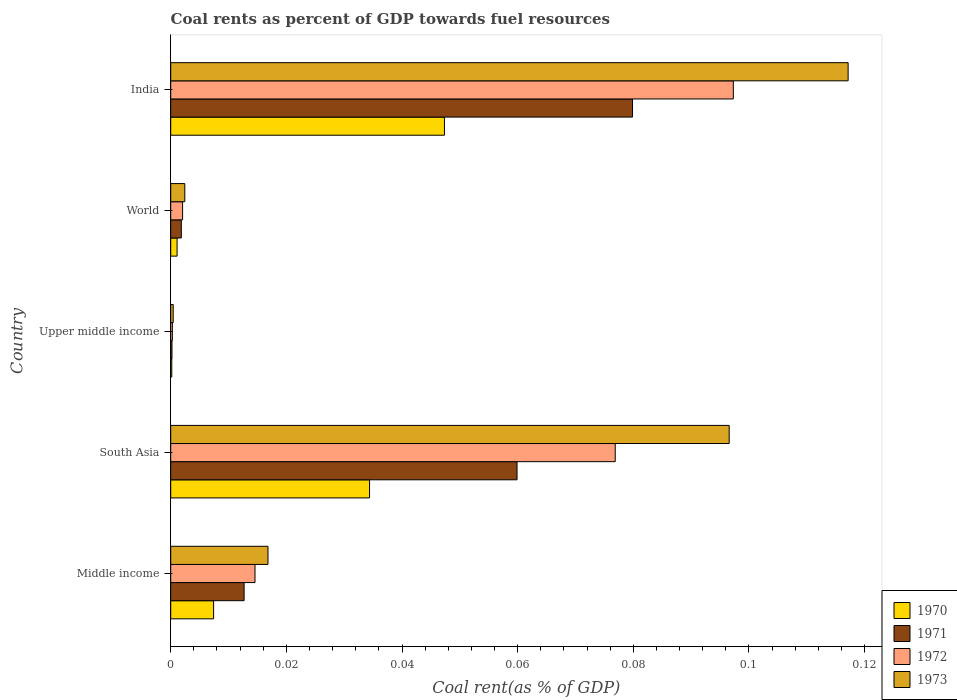How many different coloured bars are there?
Your answer should be very brief. 4. Are the number of bars per tick equal to the number of legend labels?
Give a very brief answer. Yes. How many bars are there on the 5th tick from the top?
Your answer should be very brief. 4. How many bars are there on the 2nd tick from the bottom?
Your answer should be compact. 4. What is the label of the 5th group of bars from the top?
Your answer should be compact. Middle income. In how many cases, is the number of bars for a given country not equal to the number of legend labels?
Your answer should be very brief. 0. What is the coal rent in 1972 in India?
Provide a short and direct response. 0.1. Across all countries, what is the maximum coal rent in 1971?
Provide a short and direct response. 0.08. Across all countries, what is the minimum coal rent in 1972?
Give a very brief answer. 0. In which country was the coal rent in 1973 minimum?
Offer a terse response. Upper middle income. What is the total coal rent in 1970 in the graph?
Make the answer very short. 0.09. What is the difference between the coal rent in 1973 in India and that in Upper middle income?
Your answer should be compact. 0.12. What is the difference between the coal rent in 1971 in World and the coal rent in 1972 in Upper middle income?
Offer a very short reply. 0. What is the average coal rent in 1970 per country?
Your response must be concise. 0.02. What is the difference between the coal rent in 1972 and coal rent in 1973 in South Asia?
Keep it short and to the point. -0.02. What is the ratio of the coal rent in 1973 in South Asia to that in World?
Your response must be concise. 39.65. Is the coal rent in 1972 in Upper middle income less than that in World?
Offer a terse response. Yes. What is the difference between the highest and the second highest coal rent in 1972?
Make the answer very short. 0.02. What is the difference between the highest and the lowest coal rent in 1971?
Offer a very short reply. 0.08. Is the sum of the coal rent in 1973 in India and South Asia greater than the maximum coal rent in 1972 across all countries?
Provide a short and direct response. Yes. What does the 4th bar from the bottom in Upper middle income represents?
Ensure brevity in your answer.  1973. Are all the bars in the graph horizontal?
Make the answer very short. Yes. Are the values on the major ticks of X-axis written in scientific E-notation?
Offer a very short reply. No. Does the graph contain grids?
Provide a succinct answer. No. How many legend labels are there?
Give a very brief answer. 4. How are the legend labels stacked?
Offer a terse response. Vertical. What is the title of the graph?
Offer a terse response. Coal rents as percent of GDP towards fuel resources. Does "1973" appear as one of the legend labels in the graph?
Offer a very short reply. Yes. What is the label or title of the X-axis?
Make the answer very short. Coal rent(as % of GDP). What is the label or title of the Y-axis?
Give a very brief answer. Country. What is the Coal rent(as % of GDP) of 1970 in Middle income?
Offer a terse response. 0.01. What is the Coal rent(as % of GDP) in 1971 in Middle income?
Make the answer very short. 0.01. What is the Coal rent(as % of GDP) of 1972 in Middle income?
Your answer should be very brief. 0.01. What is the Coal rent(as % of GDP) of 1973 in Middle income?
Ensure brevity in your answer.  0.02. What is the Coal rent(as % of GDP) of 1970 in South Asia?
Make the answer very short. 0.03. What is the Coal rent(as % of GDP) of 1971 in South Asia?
Keep it short and to the point. 0.06. What is the Coal rent(as % of GDP) in 1972 in South Asia?
Offer a very short reply. 0.08. What is the Coal rent(as % of GDP) in 1973 in South Asia?
Offer a very short reply. 0.1. What is the Coal rent(as % of GDP) in 1970 in Upper middle income?
Ensure brevity in your answer.  0. What is the Coal rent(as % of GDP) of 1971 in Upper middle income?
Provide a succinct answer. 0. What is the Coal rent(as % of GDP) of 1972 in Upper middle income?
Give a very brief answer. 0. What is the Coal rent(as % of GDP) in 1973 in Upper middle income?
Ensure brevity in your answer.  0. What is the Coal rent(as % of GDP) of 1970 in World?
Keep it short and to the point. 0. What is the Coal rent(as % of GDP) of 1971 in World?
Offer a terse response. 0. What is the Coal rent(as % of GDP) of 1972 in World?
Make the answer very short. 0. What is the Coal rent(as % of GDP) of 1973 in World?
Offer a terse response. 0. What is the Coal rent(as % of GDP) of 1970 in India?
Offer a terse response. 0.05. What is the Coal rent(as % of GDP) in 1971 in India?
Provide a short and direct response. 0.08. What is the Coal rent(as % of GDP) of 1972 in India?
Give a very brief answer. 0.1. What is the Coal rent(as % of GDP) in 1973 in India?
Keep it short and to the point. 0.12. Across all countries, what is the maximum Coal rent(as % of GDP) in 1970?
Your answer should be compact. 0.05. Across all countries, what is the maximum Coal rent(as % of GDP) of 1971?
Your answer should be very brief. 0.08. Across all countries, what is the maximum Coal rent(as % of GDP) in 1972?
Your answer should be very brief. 0.1. Across all countries, what is the maximum Coal rent(as % of GDP) of 1973?
Provide a succinct answer. 0.12. Across all countries, what is the minimum Coal rent(as % of GDP) in 1970?
Offer a terse response. 0. Across all countries, what is the minimum Coal rent(as % of GDP) of 1971?
Provide a short and direct response. 0. Across all countries, what is the minimum Coal rent(as % of GDP) in 1972?
Your response must be concise. 0. Across all countries, what is the minimum Coal rent(as % of GDP) in 1973?
Offer a terse response. 0. What is the total Coal rent(as % of GDP) in 1970 in the graph?
Your answer should be compact. 0.09. What is the total Coal rent(as % of GDP) of 1971 in the graph?
Your answer should be very brief. 0.15. What is the total Coal rent(as % of GDP) in 1972 in the graph?
Keep it short and to the point. 0.19. What is the total Coal rent(as % of GDP) of 1973 in the graph?
Give a very brief answer. 0.23. What is the difference between the Coal rent(as % of GDP) in 1970 in Middle income and that in South Asia?
Give a very brief answer. -0.03. What is the difference between the Coal rent(as % of GDP) in 1971 in Middle income and that in South Asia?
Your answer should be very brief. -0.05. What is the difference between the Coal rent(as % of GDP) in 1972 in Middle income and that in South Asia?
Provide a succinct answer. -0.06. What is the difference between the Coal rent(as % of GDP) in 1973 in Middle income and that in South Asia?
Ensure brevity in your answer.  -0.08. What is the difference between the Coal rent(as % of GDP) of 1970 in Middle income and that in Upper middle income?
Ensure brevity in your answer.  0.01. What is the difference between the Coal rent(as % of GDP) of 1971 in Middle income and that in Upper middle income?
Ensure brevity in your answer.  0.01. What is the difference between the Coal rent(as % of GDP) of 1972 in Middle income and that in Upper middle income?
Provide a succinct answer. 0.01. What is the difference between the Coal rent(as % of GDP) of 1973 in Middle income and that in Upper middle income?
Keep it short and to the point. 0.02. What is the difference between the Coal rent(as % of GDP) of 1970 in Middle income and that in World?
Provide a succinct answer. 0.01. What is the difference between the Coal rent(as % of GDP) of 1971 in Middle income and that in World?
Your response must be concise. 0.01. What is the difference between the Coal rent(as % of GDP) of 1972 in Middle income and that in World?
Your answer should be compact. 0.01. What is the difference between the Coal rent(as % of GDP) in 1973 in Middle income and that in World?
Give a very brief answer. 0.01. What is the difference between the Coal rent(as % of GDP) of 1970 in Middle income and that in India?
Keep it short and to the point. -0.04. What is the difference between the Coal rent(as % of GDP) of 1971 in Middle income and that in India?
Ensure brevity in your answer.  -0.07. What is the difference between the Coal rent(as % of GDP) in 1972 in Middle income and that in India?
Your answer should be compact. -0.08. What is the difference between the Coal rent(as % of GDP) in 1973 in Middle income and that in India?
Offer a very short reply. -0.1. What is the difference between the Coal rent(as % of GDP) of 1970 in South Asia and that in Upper middle income?
Your response must be concise. 0.03. What is the difference between the Coal rent(as % of GDP) in 1971 in South Asia and that in Upper middle income?
Give a very brief answer. 0.06. What is the difference between the Coal rent(as % of GDP) in 1972 in South Asia and that in Upper middle income?
Offer a very short reply. 0.08. What is the difference between the Coal rent(as % of GDP) of 1973 in South Asia and that in Upper middle income?
Offer a terse response. 0.1. What is the difference between the Coal rent(as % of GDP) in 1970 in South Asia and that in World?
Your response must be concise. 0.03. What is the difference between the Coal rent(as % of GDP) of 1971 in South Asia and that in World?
Offer a terse response. 0.06. What is the difference between the Coal rent(as % of GDP) of 1972 in South Asia and that in World?
Provide a succinct answer. 0.07. What is the difference between the Coal rent(as % of GDP) in 1973 in South Asia and that in World?
Keep it short and to the point. 0.09. What is the difference between the Coal rent(as % of GDP) in 1970 in South Asia and that in India?
Offer a very short reply. -0.01. What is the difference between the Coal rent(as % of GDP) in 1971 in South Asia and that in India?
Keep it short and to the point. -0.02. What is the difference between the Coal rent(as % of GDP) of 1972 in South Asia and that in India?
Offer a very short reply. -0.02. What is the difference between the Coal rent(as % of GDP) in 1973 in South Asia and that in India?
Give a very brief answer. -0.02. What is the difference between the Coal rent(as % of GDP) of 1970 in Upper middle income and that in World?
Ensure brevity in your answer.  -0. What is the difference between the Coal rent(as % of GDP) in 1971 in Upper middle income and that in World?
Ensure brevity in your answer.  -0. What is the difference between the Coal rent(as % of GDP) in 1972 in Upper middle income and that in World?
Ensure brevity in your answer.  -0. What is the difference between the Coal rent(as % of GDP) in 1973 in Upper middle income and that in World?
Provide a succinct answer. -0. What is the difference between the Coal rent(as % of GDP) in 1970 in Upper middle income and that in India?
Keep it short and to the point. -0.05. What is the difference between the Coal rent(as % of GDP) in 1971 in Upper middle income and that in India?
Give a very brief answer. -0.08. What is the difference between the Coal rent(as % of GDP) in 1972 in Upper middle income and that in India?
Ensure brevity in your answer.  -0.1. What is the difference between the Coal rent(as % of GDP) of 1973 in Upper middle income and that in India?
Give a very brief answer. -0.12. What is the difference between the Coal rent(as % of GDP) in 1970 in World and that in India?
Offer a very short reply. -0.05. What is the difference between the Coal rent(as % of GDP) in 1971 in World and that in India?
Your answer should be compact. -0.08. What is the difference between the Coal rent(as % of GDP) in 1972 in World and that in India?
Offer a very short reply. -0.1. What is the difference between the Coal rent(as % of GDP) of 1973 in World and that in India?
Offer a very short reply. -0.11. What is the difference between the Coal rent(as % of GDP) of 1970 in Middle income and the Coal rent(as % of GDP) of 1971 in South Asia?
Give a very brief answer. -0.05. What is the difference between the Coal rent(as % of GDP) in 1970 in Middle income and the Coal rent(as % of GDP) in 1972 in South Asia?
Provide a short and direct response. -0.07. What is the difference between the Coal rent(as % of GDP) in 1970 in Middle income and the Coal rent(as % of GDP) in 1973 in South Asia?
Your response must be concise. -0.09. What is the difference between the Coal rent(as % of GDP) of 1971 in Middle income and the Coal rent(as % of GDP) of 1972 in South Asia?
Offer a very short reply. -0.06. What is the difference between the Coal rent(as % of GDP) in 1971 in Middle income and the Coal rent(as % of GDP) in 1973 in South Asia?
Your response must be concise. -0.08. What is the difference between the Coal rent(as % of GDP) in 1972 in Middle income and the Coal rent(as % of GDP) in 1973 in South Asia?
Your answer should be compact. -0.08. What is the difference between the Coal rent(as % of GDP) of 1970 in Middle income and the Coal rent(as % of GDP) of 1971 in Upper middle income?
Offer a terse response. 0.01. What is the difference between the Coal rent(as % of GDP) of 1970 in Middle income and the Coal rent(as % of GDP) of 1972 in Upper middle income?
Keep it short and to the point. 0.01. What is the difference between the Coal rent(as % of GDP) of 1970 in Middle income and the Coal rent(as % of GDP) of 1973 in Upper middle income?
Offer a very short reply. 0.01. What is the difference between the Coal rent(as % of GDP) in 1971 in Middle income and the Coal rent(as % of GDP) in 1972 in Upper middle income?
Keep it short and to the point. 0.01. What is the difference between the Coal rent(as % of GDP) in 1971 in Middle income and the Coal rent(as % of GDP) in 1973 in Upper middle income?
Your response must be concise. 0.01. What is the difference between the Coal rent(as % of GDP) in 1972 in Middle income and the Coal rent(as % of GDP) in 1973 in Upper middle income?
Make the answer very short. 0.01. What is the difference between the Coal rent(as % of GDP) in 1970 in Middle income and the Coal rent(as % of GDP) in 1971 in World?
Your answer should be compact. 0.01. What is the difference between the Coal rent(as % of GDP) of 1970 in Middle income and the Coal rent(as % of GDP) of 1972 in World?
Offer a terse response. 0.01. What is the difference between the Coal rent(as % of GDP) of 1970 in Middle income and the Coal rent(as % of GDP) of 1973 in World?
Offer a terse response. 0.01. What is the difference between the Coal rent(as % of GDP) of 1971 in Middle income and the Coal rent(as % of GDP) of 1972 in World?
Offer a very short reply. 0.01. What is the difference between the Coal rent(as % of GDP) in 1971 in Middle income and the Coal rent(as % of GDP) in 1973 in World?
Offer a terse response. 0.01. What is the difference between the Coal rent(as % of GDP) of 1972 in Middle income and the Coal rent(as % of GDP) of 1973 in World?
Make the answer very short. 0.01. What is the difference between the Coal rent(as % of GDP) in 1970 in Middle income and the Coal rent(as % of GDP) in 1971 in India?
Your answer should be compact. -0.07. What is the difference between the Coal rent(as % of GDP) in 1970 in Middle income and the Coal rent(as % of GDP) in 1972 in India?
Offer a terse response. -0.09. What is the difference between the Coal rent(as % of GDP) in 1970 in Middle income and the Coal rent(as % of GDP) in 1973 in India?
Make the answer very short. -0.11. What is the difference between the Coal rent(as % of GDP) in 1971 in Middle income and the Coal rent(as % of GDP) in 1972 in India?
Provide a succinct answer. -0.08. What is the difference between the Coal rent(as % of GDP) in 1971 in Middle income and the Coal rent(as % of GDP) in 1973 in India?
Provide a succinct answer. -0.1. What is the difference between the Coal rent(as % of GDP) of 1972 in Middle income and the Coal rent(as % of GDP) of 1973 in India?
Offer a very short reply. -0.1. What is the difference between the Coal rent(as % of GDP) of 1970 in South Asia and the Coal rent(as % of GDP) of 1971 in Upper middle income?
Give a very brief answer. 0.03. What is the difference between the Coal rent(as % of GDP) of 1970 in South Asia and the Coal rent(as % of GDP) of 1972 in Upper middle income?
Keep it short and to the point. 0.03. What is the difference between the Coal rent(as % of GDP) in 1970 in South Asia and the Coal rent(as % of GDP) in 1973 in Upper middle income?
Give a very brief answer. 0.03. What is the difference between the Coal rent(as % of GDP) of 1971 in South Asia and the Coal rent(as % of GDP) of 1972 in Upper middle income?
Keep it short and to the point. 0.06. What is the difference between the Coal rent(as % of GDP) of 1971 in South Asia and the Coal rent(as % of GDP) of 1973 in Upper middle income?
Your answer should be very brief. 0.06. What is the difference between the Coal rent(as % of GDP) of 1972 in South Asia and the Coal rent(as % of GDP) of 1973 in Upper middle income?
Your answer should be compact. 0.08. What is the difference between the Coal rent(as % of GDP) in 1970 in South Asia and the Coal rent(as % of GDP) in 1971 in World?
Give a very brief answer. 0.03. What is the difference between the Coal rent(as % of GDP) in 1970 in South Asia and the Coal rent(as % of GDP) in 1972 in World?
Ensure brevity in your answer.  0.03. What is the difference between the Coal rent(as % of GDP) of 1970 in South Asia and the Coal rent(as % of GDP) of 1973 in World?
Offer a terse response. 0.03. What is the difference between the Coal rent(as % of GDP) in 1971 in South Asia and the Coal rent(as % of GDP) in 1972 in World?
Offer a terse response. 0.06. What is the difference between the Coal rent(as % of GDP) of 1971 in South Asia and the Coal rent(as % of GDP) of 1973 in World?
Your response must be concise. 0.06. What is the difference between the Coal rent(as % of GDP) in 1972 in South Asia and the Coal rent(as % of GDP) in 1973 in World?
Keep it short and to the point. 0.07. What is the difference between the Coal rent(as % of GDP) of 1970 in South Asia and the Coal rent(as % of GDP) of 1971 in India?
Provide a short and direct response. -0.05. What is the difference between the Coal rent(as % of GDP) in 1970 in South Asia and the Coal rent(as % of GDP) in 1972 in India?
Offer a terse response. -0.06. What is the difference between the Coal rent(as % of GDP) of 1970 in South Asia and the Coal rent(as % of GDP) of 1973 in India?
Give a very brief answer. -0.08. What is the difference between the Coal rent(as % of GDP) in 1971 in South Asia and the Coal rent(as % of GDP) in 1972 in India?
Your response must be concise. -0.04. What is the difference between the Coal rent(as % of GDP) in 1971 in South Asia and the Coal rent(as % of GDP) in 1973 in India?
Offer a very short reply. -0.06. What is the difference between the Coal rent(as % of GDP) in 1972 in South Asia and the Coal rent(as % of GDP) in 1973 in India?
Your answer should be compact. -0.04. What is the difference between the Coal rent(as % of GDP) of 1970 in Upper middle income and the Coal rent(as % of GDP) of 1971 in World?
Your answer should be compact. -0. What is the difference between the Coal rent(as % of GDP) of 1970 in Upper middle income and the Coal rent(as % of GDP) of 1972 in World?
Make the answer very short. -0. What is the difference between the Coal rent(as % of GDP) in 1970 in Upper middle income and the Coal rent(as % of GDP) in 1973 in World?
Keep it short and to the point. -0. What is the difference between the Coal rent(as % of GDP) of 1971 in Upper middle income and the Coal rent(as % of GDP) of 1972 in World?
Provide a succinct answer. -0. What is the difference between the Coal rent(as % of GDP) of 1971 in Upper middle income and the Coal rent(as % of GDP) of 1973 in World?
Ensure brevity in your answer.  -0. What is the difference between the Coal rent(as % of GDP) in 1972 in Upper middle income and the Coal rent(as % of GDP) in 1973 in World?
Provide a succinct answer. -0. What is the difference between the Coal rent(as % of GDP) in 1970 in Upper middle income and the Coal rent(as % of GDP) in 1971 in India?
Ensure brevity in your answer.  -0.08. What is the difference between the Coal rent(as % of GDP) in 1970 in Upper middle income and the Coal rent(as % of GDP) in 1972 in India?
Your response must be concise. -0.1. What is the difference between the Coal rent(as % of GDP) of 1970 in Upper middle income and the Coal rent(as % of GDP) of 1973 in India?
Your answer should be compact. -0.12. What is the difference between the Coal rent(as % of GDP) in 1971 in Upper middle income and the Coal rent(as % of GDP) in 1972 in India?
Make the answer very short. -0.1. What is the difference between the Coal rent(as % of GDP) in 1971 in Upper middle income and the Coal rent(as % of GDP) in 1973 in India?
Ensure brevity in your answer.  -0.12. What is the difference between the Coal rent(as % of GDP) in 1972 in Upper middle income and the Coal rent(as % of GDP) in 1973 in India?
Provide a succinct answer. -0.12. What is the difference between the Coal rent(as % of GDP) in 1970 in World and the Coal rent(as % of GDP) in 1971 in India?
Make the answer very short. -0.08. What is the difference between the Coal rent(as % of GDP) in 1970 in World and the Coal rent(as % of GDP) in 1972 in India?
Ensure brevity in your answer.  -0.1. What is the difference between the Coal rent(as % of GDP) of 1970 in World and the Coal rent(as % of GDP) of 1973 in India?
Provide a succinct answer. -0.12. What is the difference between the Coal rent(as % of GDP) of 1971 in World and the Coal rent(as % of GDP) of 1972 in India?
Provide a succinct answer. -0.1. What is the difference between the Coal rent(as % of GDP) of 1971 in World and the Coal rent(as % of GDP) of 1973 in India?
Give a very brief answer. -0.12. What is the difference between the Coal rent(as % of GDP) in 1972 in World and the Coal rent(as % of GDP) in 1973 in India?
Ensure brevity in your answer.  -0.12. What is the average Coal rent(as % of GDP) of 1970 per country?
Provide a succinct answer. 0.02. What is the average Coal rent(as % of GDP) in 1971 per country?
Offer a very short reply. 0.03. What is the average Coal rent(as % of GDP) in 1972 per country?
Your response must be concise. 0.04. What is the average Coal rent(as % of GDP) in 1973 per country?
Keep it short and to the point. 0.05. What is the difference between the Coal rent(as % of GDP) of 1970 and Coal rent(as % of GDP) of 1971 in Middle income?
Your answer should be compact. -0.01. What is the difference between the Coal rent(as % of GDP) in 1970 and Coal rent(as % of GDP) in 1972 in Middle income?
Give a very brief answer. -0.01. What is the difference between the Coal rent(as % of GDP) in 1970 and Coal rent(as % of GDP) in 1973 in Middle income?
Make the answer very short. -0.01. What is the difference between the Coal rent(as % of GDP) of 1971 and Coal rent(as % of GDP) of 1972 in Middle income?
Make the answer very short. -0. What is the difference between the Coal rent(as % of GDP) in 1971 and Coal rent(as % of GDP) in 1973 in Middle income?
Make the answer very short. -0. What is the difference between the Coal rent(as % of GDP) in 1972 and Coal rent(as % of GDP) in 1973 in Middle income?
Offer a very short reply. -0. What is the difference between the Coal rent(as % of GDP) of 1970 and Coal rent(as % of GDP) of 1971 in South Asia?
Offer a very short reply. -0.03. What is the difference between the Coal rent(as % of GDP) of 1970 and Coal rent(as % of GDP) of 1972 in South Asia?
Make the answer very short. -0.04. What is the difference between the Coal rent(as % of GDP) in 1970 and Coal rent(as % of GDP) in 1973 in South Asia?
Your answer should be compact. -0.06. What is the difference between the Coal rent(as % of GDP) in 1971 and Coal rent(as % of GDP) in 1972 in South Asia?
Offer a very short reply. -0.02. What is the difference between the Coal rent(as % of GDP) of 1971 and Coal rent(as % of GDP) of 1973 in South Asia?
Your answer should be very brief. -0.04. What is the difference between the Coal rent(as % of GDP) of 1972 and Coal rent(as % of GDP) of 1973 in South Asia?
Offer a very short reply. -0.02. What is the difference between the Coal rent(as % of GDP) of 1970 and Coal rent(as % of GDP) of 1972 in Upper middle income?
Keep it short and to the point. -0. What is the difference between the Coal rent(as % of GDP) in 1970 and Coal rent(as % of GDP) in 1973 in Upper middle income?
Ensure brevity in your answer.  -0. What is the difference between the Coal rent(as % of GDP) of 1971 and Coal rent(as % of GDP) of 1972 in Upper middle income?
Your response must be concise. -0. What is the difference between the Coal rent(as % of GDP) of 1971 and Coal rent(as % of GDP) of 1973 in Upper middle income?
Give a very brief answer. -0. What is the difference between the Coal rent(as % of GDP) in 1972 and Coal rent(as % of GDP) in 1973 in Upper middle income?
Provide a short and direct response. -0. What is the difference between the Coal rent(as % of GDP) of 1970 and Coal rent(as % of GDP) of 1971 in World?
Offer a terse response. -0. What is the difference between the Coal rent(as % of GDP) in 1970 and Coal rent(as % of GDP) in 1972 in World?
Provide a succinct answer. -0. What is the difference between the Coal rent(as % of GDP) of 1970 and Coal rent(as % of GDP) of 1973 in World?
Provide a short and direct response. -0. What is the difference between the Coal rent(as % of GDP) of 1971 and Coal rent(as % of GDP) of 1972 in World?
Your response must be concise. -0. What is the difference between the Coal rent(as % of GDP) in 1971 and Coal rent(as % of GDP) in 1973 in World?
Offer a terse response. -0. What is the difference between the Coal rent(as % of GDP) in 1972 and Coal rent(as % of GDP) in 1973 in World?
Offer a terse response. -0. What is the difference between the Coal rent(as % of GDP) of 1970 and Coal rent(as % of GDP) of 1971 in India?
Provide a short and direct response. -0.03. What is the difference between the Coal rent(as % of GDP) of 1970 and Coal rent(as % of GDP) of 1973 in India?
Make the answer very short. -0.07. What is the difference between the Coal rent(as % of GDP) of 1971 and Coal rent(as % of GDP) of 1972 in India?
Provide a succinct answer. -0.02. What is the difference between the Coal rent(as % of GDP) in 1971 and Coal rent(as % of GDP) in 1973 in India?
Your answer should be very brief. -0.04. What is the difference between the Coal rent(as % of GDP) of 1972 and Coal rent(as % of GDP) of 1973 in India?
Offer a very short reply. -0.02. What is the ratio of the Coal rent(as % of GDP) of 1970 in Middle income to that in South Asia?
Make the answer very short. 0.22. What is the ratio of the Coal rent(as % of GDP) of 1971 in Middle income to that in South Asia?
Your answer should be compact. 0.21. What is the ratio of the Coal rent(as % of GDP) in 1972 in Middle income to that in South Asia?
Keep it short and to the point. 0.19. What is the ratio of the Coal rent(as % of GDP) in 1973 in Middle income to that in South Asia?
Provide a short and direct response. 0.17. What is the ratio of the Coal rent(as % of GDP) in 1970 in Middle income to that in Upper middle income?
Your response must be concise. 40.36. What is the ratio of the Coal rent(as % of GDP) of 1971 in Middle income to that in Upper middle income?
Give a very brief answer. 58.01. What is the ratio of the Coal rent(as % of GDP) in 1972 in Middle income to that in Upper middle income?
Offer a terse response. 51.25. What is the ratio of the Coal rent(as % of GDP) of 1973 in Middle income to that in Upper middle income?
Provide a short and direct response. 39.04. What is the ratio of the Coal rent(as % of GDP) in 1970 in Middle income to that in World?
Provide a short and direct response. 6.74. What is the ratio of the Coal rent(as % of GDP) of 1971 in Middle income to that in World?
Give a very brief answer. 6.93. What is the ratio of the Coal rent(as % of GDP) in 1972 in Middle income to that in World?
Your answer should be very brief. 7.09. What is the ratio of the Coal rent(as % of GDP) in 1973 in Middle income to that in World?
Give a very brief answer. 6.91. What is the ratio of the Coal rent(as % of GDP) in 1970 in Middle income to that in India?
Provide a succinct answer. 0.16. What is the ratio of the Coal rent(as % of GDP) in 1971 in Middle income to that in India?
Your response must be concise. 0.16. What is the ratio of the Coal rent(as % of GDP) of 1972 in Middle income to that in India?
Make the answer very short. 0.15. What is the ratio of the Coal rent(as % of GDP) in 1973 in Middle income to that in India?
Give a very brief answer. 0.14. What is the ratio of the Coal rent(as % of GDP) of 1970 in South Asia to that in Upper middle income?
Provide a succinct answer. 187.05. What is the ratio of the Coal rent(as % of GDP) of 1971 in South Asia to that in Upper middle income?
Ensure brevity in your answer.  273.74. What is the ratio of the Coal rent(as % of GDP) of 1972 in South Asia to that in Upper middle income?
Offer a very short reply. 270.32. What is the ratio of the Coal rent(as % of GDP) in 1973 in South Asia to that in Upper middle income?
Ensure brevity in your answer.  224.18. What is the ratio of the Coal rent(as % of GDP) of 1970 in South Asia to that in World?
Offer a very short reply. 31.24. What is the ratio of the Coal rent(as % of GDP) of 1971 in South Asia to that in World?
Ensure brevity in your answer.  32.69. What is the ratio of the Coal rent(as % of GDP) in 1972 in South Asia to that in World?
Provide a short and direct response. 37.41. What is the ratio of the Coal rent(as % of GDP) in 1973 in South Asia to that in World?
Offer a very short reply. 39.65. What is the ratio of the Coal rent(as % of GDP) of 1970 in South Asia to that in India?
Offer a terse response. 0.73. What is the ratio of the Coal rent(as % of GDP) of 1971 in South Asia to that in India?
Your response must be concise. 0.75. What is the ratio of the Coal rent(as % of GDP) in 1972 in South Asia to that in India?
Your response must be concise. 0.79. What is the ratio of the Coal rent(as % of GDP) in 1973 in South Asia to that in India?
Your response must be concise. 0.82. What is the ratio of the Coal rent(as % of GDP) in 1970 in Upper middle income to that in World?
Your answer should be very brief. 0.17. What is the ratio of the Coal rent(as % of GDP) in 1971 in Upper middle income to that in World?
Offer a terse response. 0.12. What is the ratio of the Coal rent(as % of GDP) in 1972 in Upper middle income to that in World?
Ensure brevity in your answer.  0.14. What is the ratio of the Coal rent(as % of GDP) of 1973 in Upper middle income to that in World?
Keep it short and to the point. 0.18. What is the ratio of the Coal rent(as % of GDP) in 1970 in Upper middle income to that in India?
Your answer should be compact. 0. What is the ratio of the Coal rent(as % of GDP) in 1971 in Upper middle income to that in India?
Keep it short and to the point. 0. What is the ratio of the Coal rent(as % of GDP) in 1972 in Upper middle income to that in India?
Offer a very short reply. 0. What is the ratio of the Coal rent(as % of GDP) in 1973 in Upper middle income to that in India?
Ensure brevity in your answer.  0. What is the ratio of the Coal rent(as % of GDP) in 1970 in World to that in India?
Provide a succinct answer. 0.02. What is the ratio of the Coal rent(as % of GDP) in 1971 in World to that in India?
Provide a short and direct response. 0.02. What is the ratio of the Coal rent(as % of GDP) of 1972 in World to that in India?
Offer a very short reply. 0.02. What is the ratio of the Coal rent(as % of GDP) in 1973 in World to that in India?
Offer a very short reply. 0.02. What is the difference between the highest and the second highest Coal rent(as % of GDP) in 1970?
Your answer should be very brief. 0.01. What is the difference between the highest and the second highest Coal rent(as % of GDP) of 1971?
Offer a very short reply. 0.02. What is the difference between the highest and the second highest Coal rent(as % of GDP) of 1972?
Ensure brevity in your answer.  0.02. What is the difference between the highest and the second highest Coal rent(as % of GDP) in 1973?
Offer a very short reply. 0.02. What is the difference between the highest and the lowest Coal rent(as % of GDP) of 1970?
Make the answer very short. 0.05. What is the difference between the highest and the lowest Coal rent(as % of GDP) in 1971?
Offer a terse response. 0.08. What is the difference between the highest and the lowest Coal rent(as % of GDP) of 1972?
Provide a succinct answer. 0.1. What is the difference between the highest and the lowest Coal rent(as % of GDP) of 1973?
Offer a terse response. 0.12. 